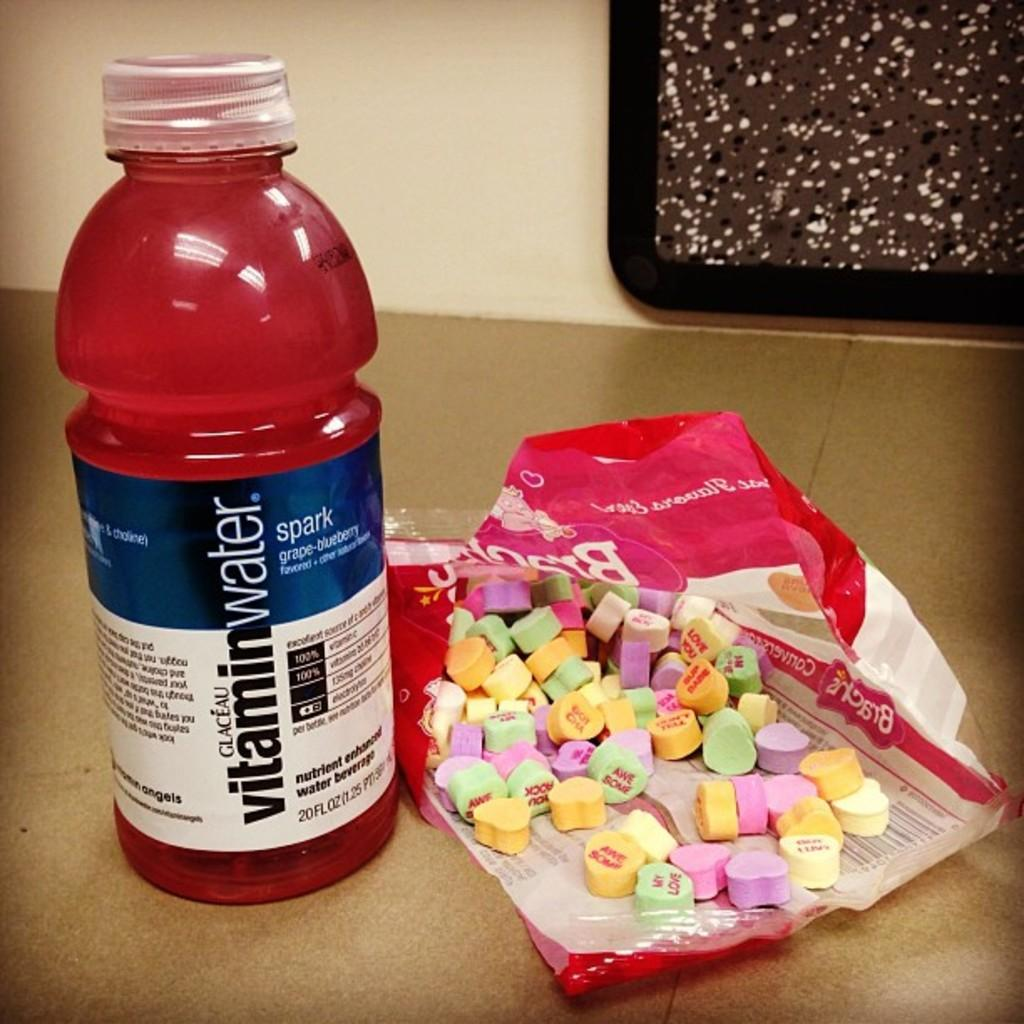<image>
Write a terse but informative summary of the picture. Red bottle of Vitamin water next to some Valentine's candy. 